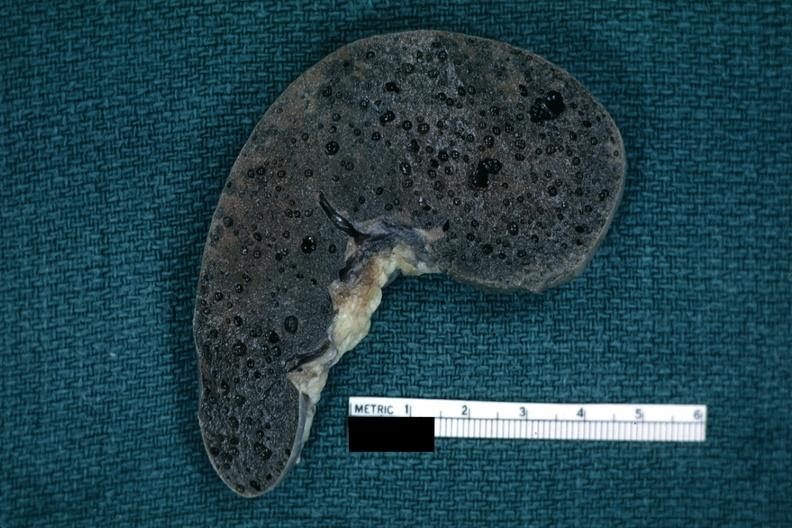what is present?
Answer the question using a single word or phrase. Clostridial postmortem growth 